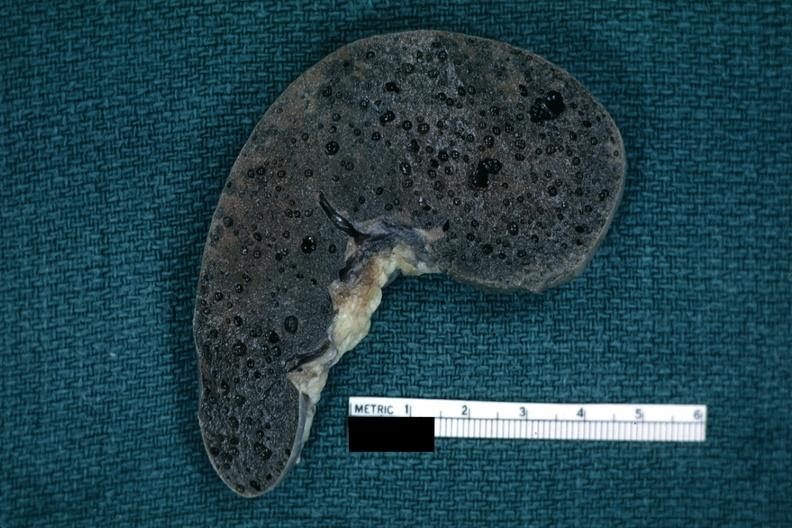what is present?
Answer the question using a single word or phrase. Clostridial postmortem growth 